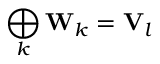<formula> <loc_0><loc_0><loc_500><loc_500>\bigoplus _ { k } W _ { k } = V _ { l }</formula> 